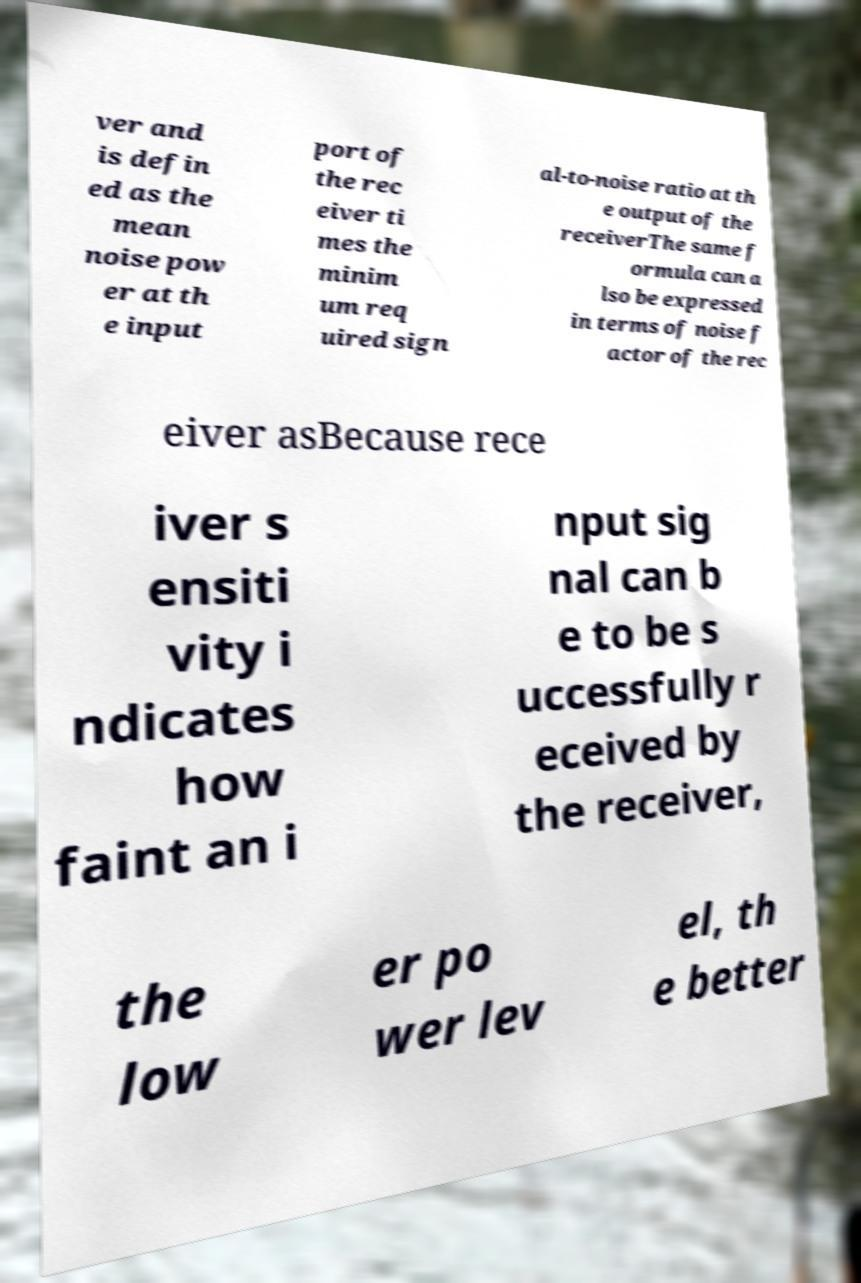Can you accurately transcribe the text from the provided image for me? ver and is defin ed as the mean noise pow er at th e input port of the rec eiver ti mes the minim um req uired sign al-to-noise ratio at th e output of the receiverThe same f ormula can a lso be expressed in terms of noise f actor of the rec eiver asBecause rece iver s ensiti vity i ndicates how faint an i nput sig nal can b e to be s uccessfully r eceived by the receiver, the low er po wer lev el, th e better 